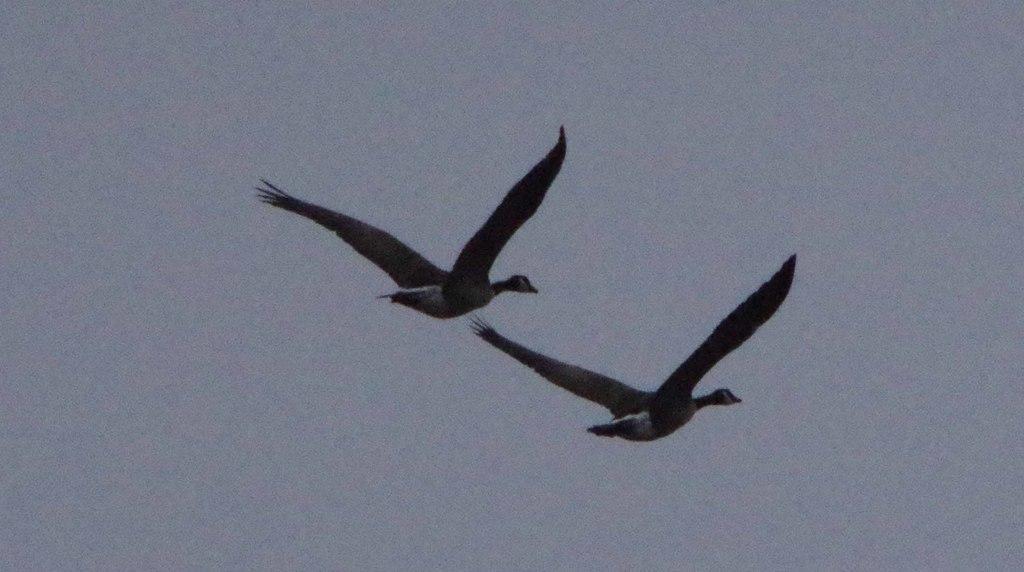Can you describe this image briefly? In the center of the image we can see birds in the sky. 